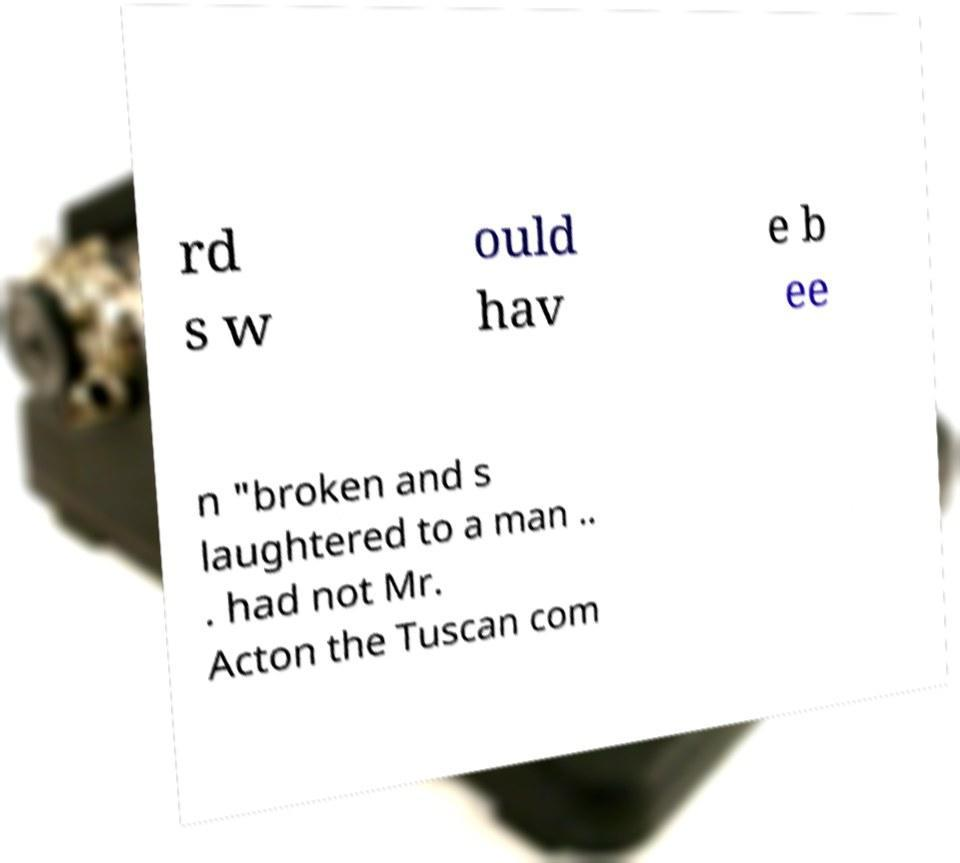Can you accurately transcribe the text from the provided image for me? rd s w ould hav e b ee n "broken and s laughtered to a man .. . had not Mr. Acton the Tuscan com 